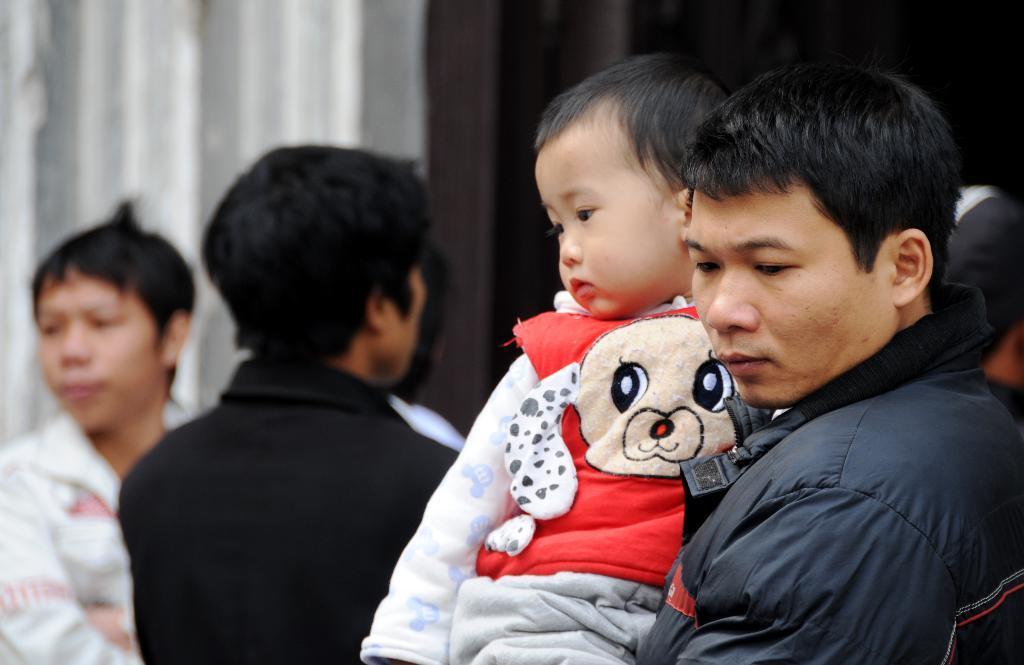Can you describe this image briefly? In front of the picture, we see the man is carrying a boy who is wearing the red jacket. Behind them, we see many people are standing. In the background, we see a wall in white and brown color. 